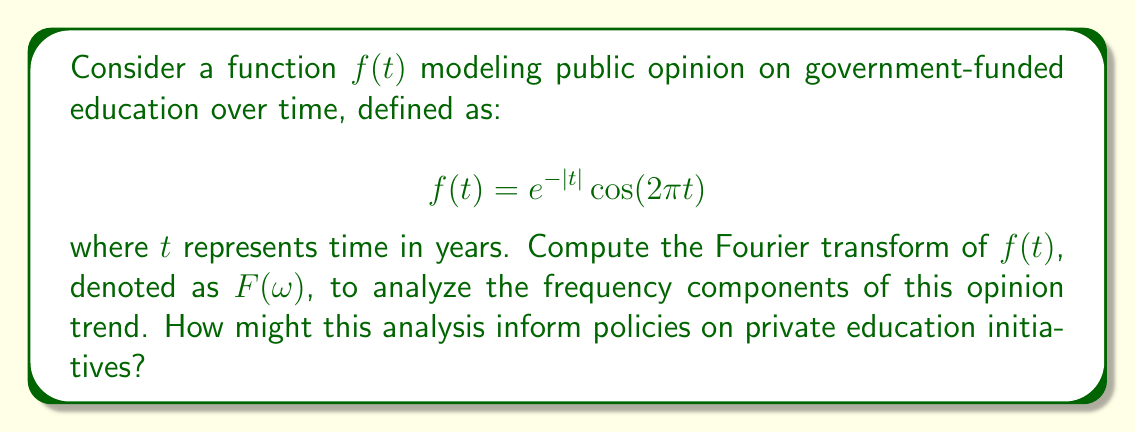Can you solve this math problem? To compute the Fourier transform of $f(t) = e^{-|t|} \cos(2\pi t)$, we follow these steps:

1) The Fourier transform is defined as:
   $$F(\omega) = \int_{-\infty}^{\infty} f(t) e^{-i\omega t} dt$$

2) Our function can be written as the sum of two complex exponentials:
   $$f(t) = e^{-|t|} \cos(2\pi t) = \frac{1}{2}e^{-|t|}(e^{i2\pi t} + e^{-i2\pi t})$$

3) The Fourier transform of $e^{-|t|}e^{i2\pi t}$ is known to be:
   $$\frac{1}{1 + i(\omega - 2\pi)}$$

4) Similarly, the Fourier transform of $e^{-|t|}e^{-i2\pi t}$ is:
   $$\frac{1}{1 + i(\omega + 2\pi)}$$

5) Therefore, the Fourier transform of $f(t)$ is:
   $$F(\omega) = \frac{1}{2} \left(\frac{1}{1 + i(\omega - 2\pi)} + \frac{1}{1 + i(\omega + 2\pi)}\right)$$

6) Simplifying:
   $$F(\omega) = \frac{1}{2} \left(\frac{1 - i(\omega - 2\pi)}{1 + (\omega - 2\pi)^2} + \frac{1 - i(\omega + 2\pi)}{1 + (\omega + 2\pi)^2}\right)$$

7) Combining terms:
   $$F(\omega) = \frac{1 + 4\pi^2 - \omega^2}{(1 + (\omega - 2\pi)^2)(1 + (\omega + 2\pi)^2)}$$

This result shows the frequency components of the public opinion trend, which could inform policies on private education initiatives by highlighting the periodicity and strength of opinion shifts.
Answer: $$F(\omega) = \frac{1 + 4\pi^2 - \omega^2}{(1 + (\omega - 2\pi)^2)(1 + (\omega + 2\pi)^2)}$$ 